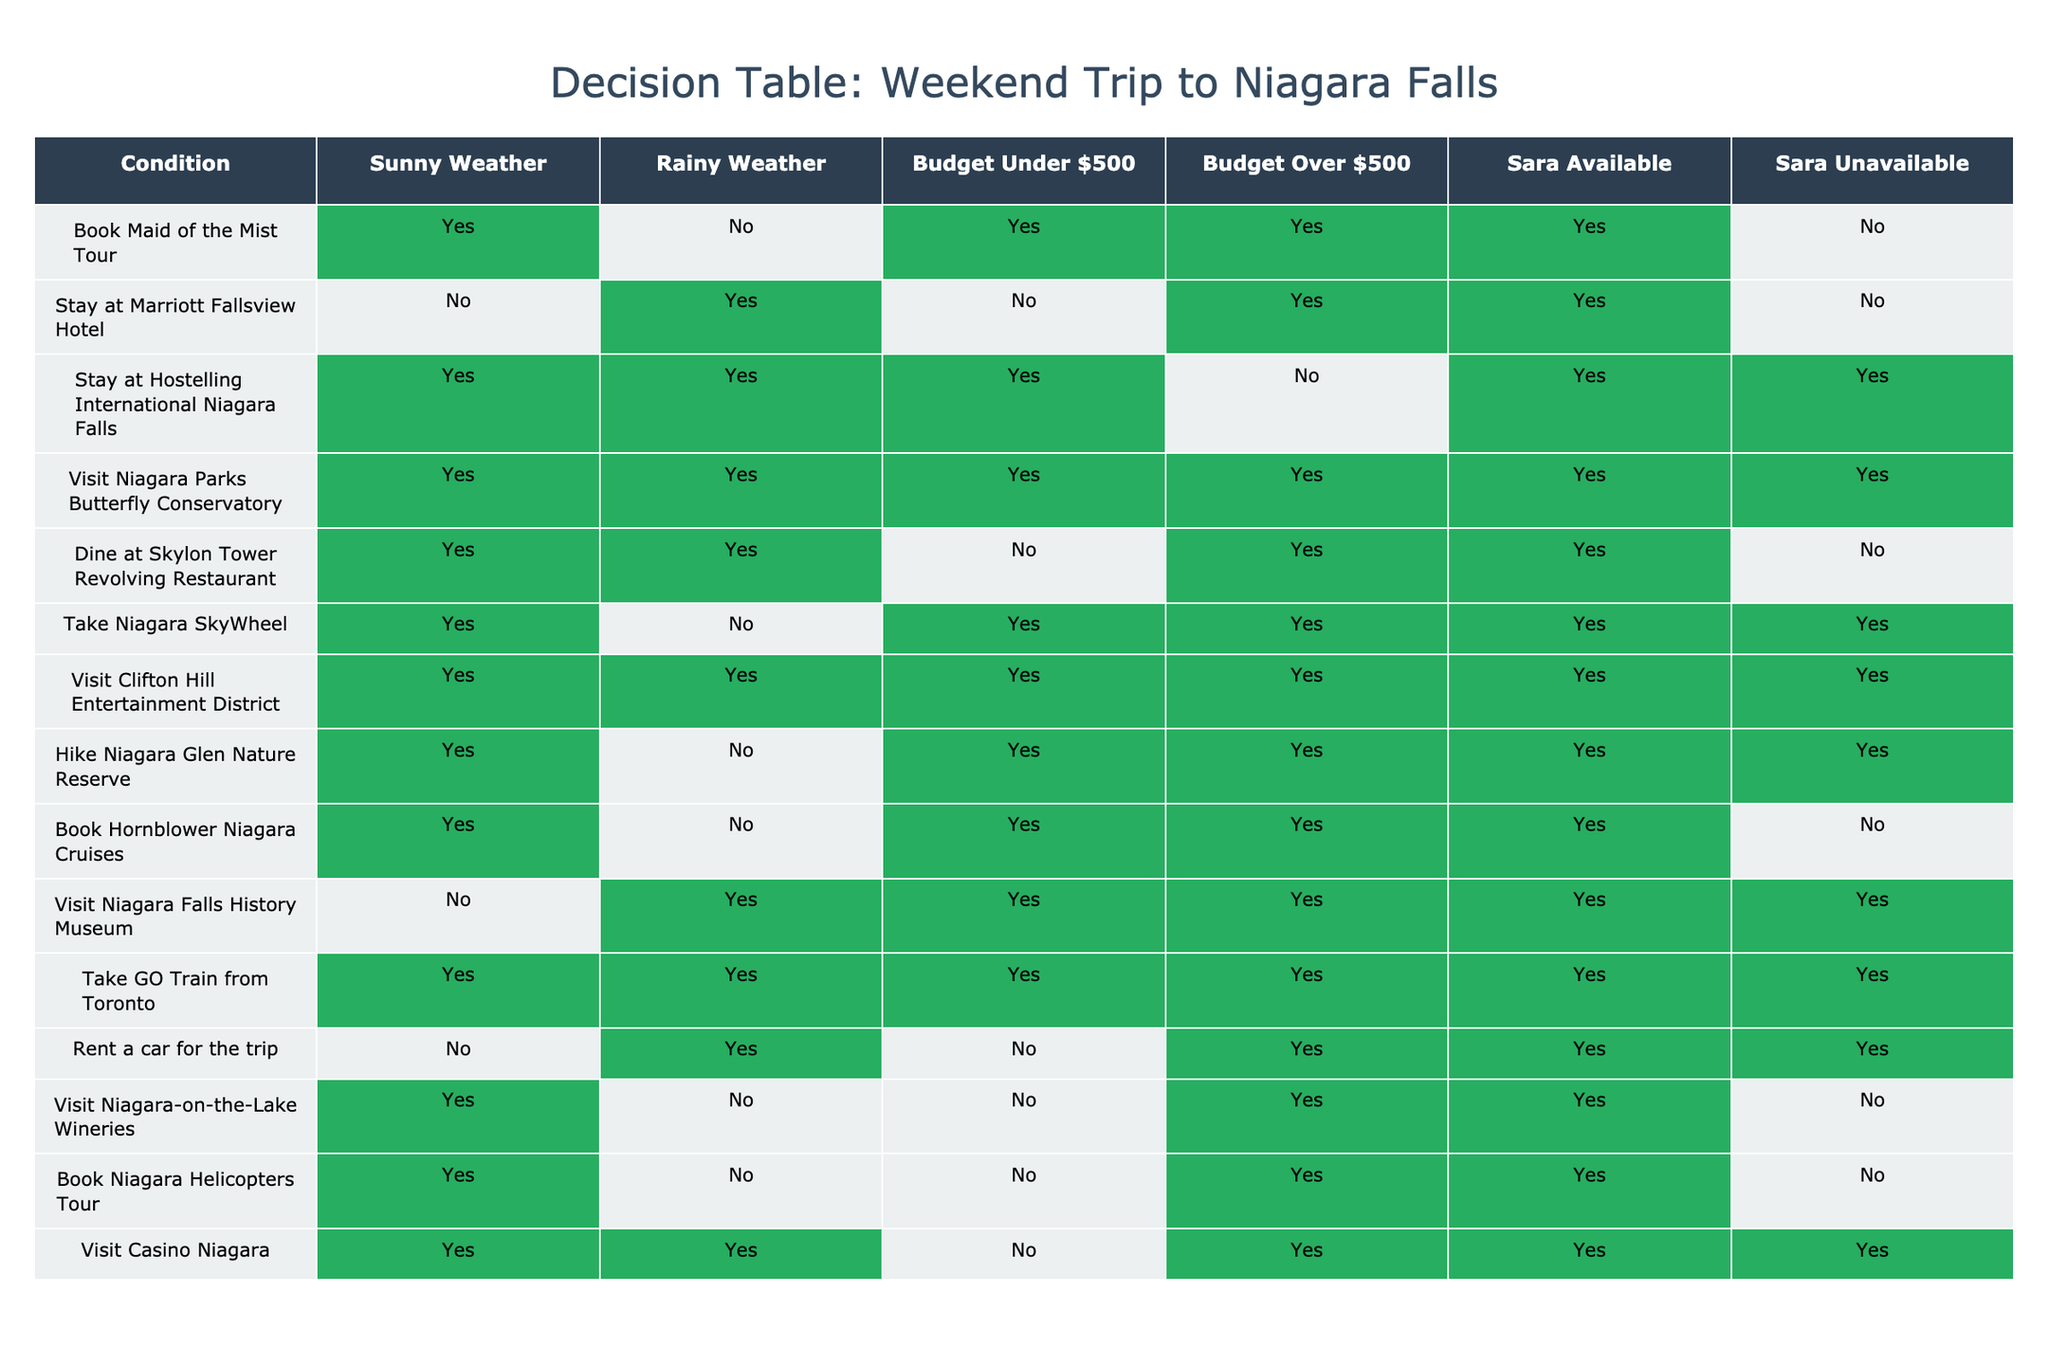What activities can we do if the weather is sunny? Looking at the sunny weather row, we can do the following activities: Book Maid of the Mist Tour, Stay at Hostelling International Niagara Falls, Visit Niagara Parks Butterfly Conservatory, Dine at Skylon Tower Revolving Restaurant, Take Niagara SkyWheel, Visit Clifton Hill Entertainment District, Hike Niagara Glen Nature Reserve, Book Hornblower Niagara Cruises, Visit Casino Niagara.
Answer: Maid of the Mist Tour, Hostelling International, Butterfly Conservatory, Skylon Tower, SkyWheel, Clifton Hill, Niagara Glen, Hornblower, Casino Niagara Is renting a car an option if Sara is unavailable? The table shows that renting a car is marked as "Yes" only if Sara is available. Therefore, if Sara is unavailable, we cannot rent a car.
Answer: No How many activities can we do if our budget is under $500? For budget under $500, we have the following activities: Book Maid of the Mist Tour, Stay at Hostelling International Niagara Falls, Visit Niagara Parks Butterfly Conservatory, Take Niagara SkyWheel, Visit Clifton Hill Entertainment District, Hike Niagara Glen Nature Reserve, Visit Niagara Falls History Museum, Take GO Train from Toronto. Counting these gives us 8 activities.
Answer: 8 What is the maximum number of activities we can do with a budget over $500 and sunny weather? In the budget over $500 and sunny weather scenario, we have the following activities: Stay at Marriott Fallsview Hotel, Dine at Skylon Tower Revolving Restaurant, Book Niagara Helicopters Tour, Visit Casino Niagara. This results in a total of 4 activities.
Answer: 4 Can we visit Niagara-on-the-Lake Wineries on a rainy day with Sara available? The table indicates that visiting Niagara-on-the-Lake Wineries is "No" for all conditions when Sara is available. Thus, this activity is not an option if it is rainy and Sara is available.
Answer: No If we go for a rainy weekend, which activities can we still do? For rainy weather, the activities available include: Stay at Marriott Fallsview Hotel, Stay at Hostelling International Niagara Falls, Visit Niagara Parks Butterfly Conservatory, Visit Niagara Falls History Museum, Take GO Train from Toronto, Rent a car for the trip, and Visit Casino Niagara. This totals 7 activities.
Answer: 7 How many activities can we do only if the weather is sunny and Sara is unavailable? Looking at the sunny weather row for when Sara is unavailable, the activities we can do are: Stay at Hostelling International Niagara Falls, Take Niagara SkyWheel, and Visit Clifton Hill Entertainment District. This gives us a total of 3 activities available under those conditions.
Answer: 3 Are we able to book Hornblower Niagara Cruises if we have a budget over $500 and Sara is unavailable? The table indicates that booking Hornblower Niagara Cruises is "No" when Sara is unavailable, regardless of the budget. Hence, we cannot book the cruise under those conditions.
Answer: No 